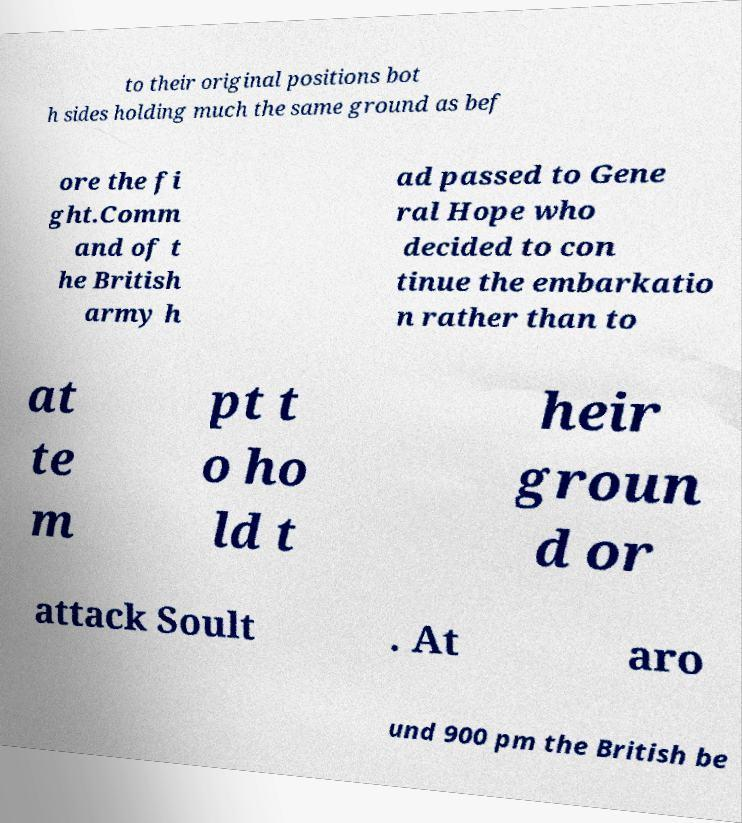Can you accurately transcribe the text from the provided image for me? to their original positions bot h sides holding much the same ground as bef ore the fi ght.Comm and of t he British army h ad passed to Gene ral Hope who decided to con tinue the embarkatio n rather than to at te m pt t o ho ld t heir groun d or attack Soult . At aro und 900 pm the British be 